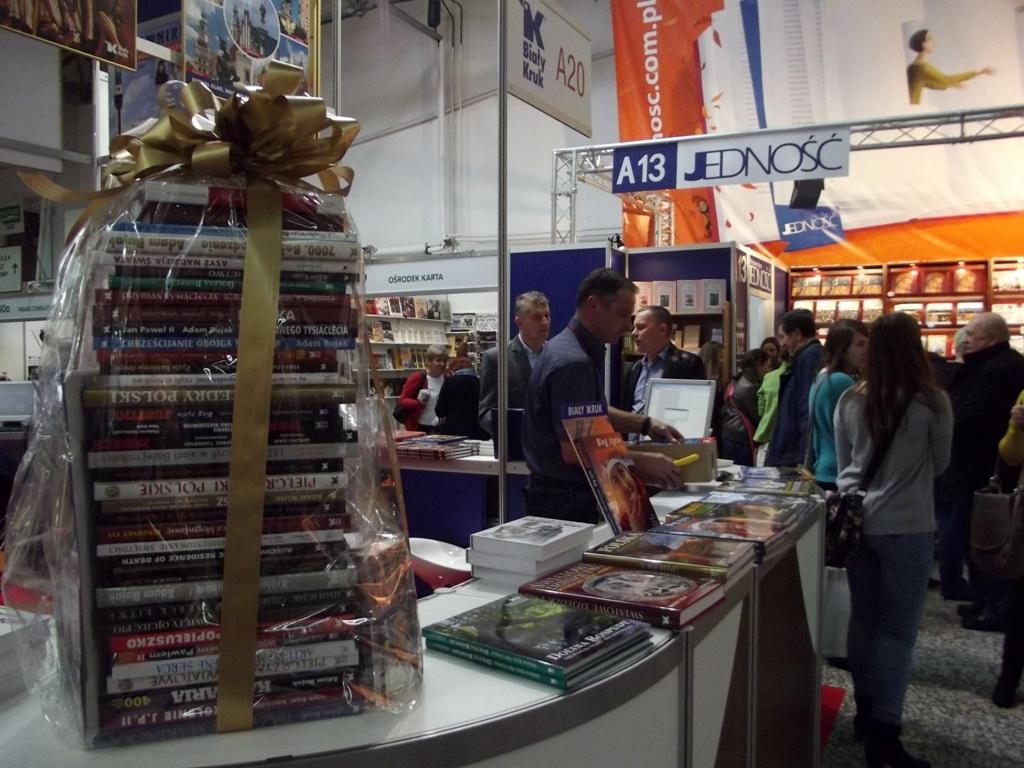What number is next to the letter a in the sign?
Your answer should be compact. 13. What section are they in?
Your answer should be very brief. A13. 